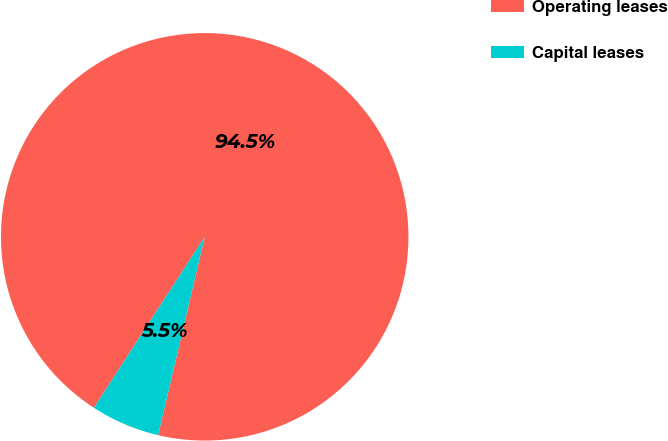<chart> <loc_0><loc_0><loc_500><loc_500><pie_chart><fcel>Operating leases<fcel>Capital leases<nl><fcel>94.52%<fcel>5.48%<nl></chart> 